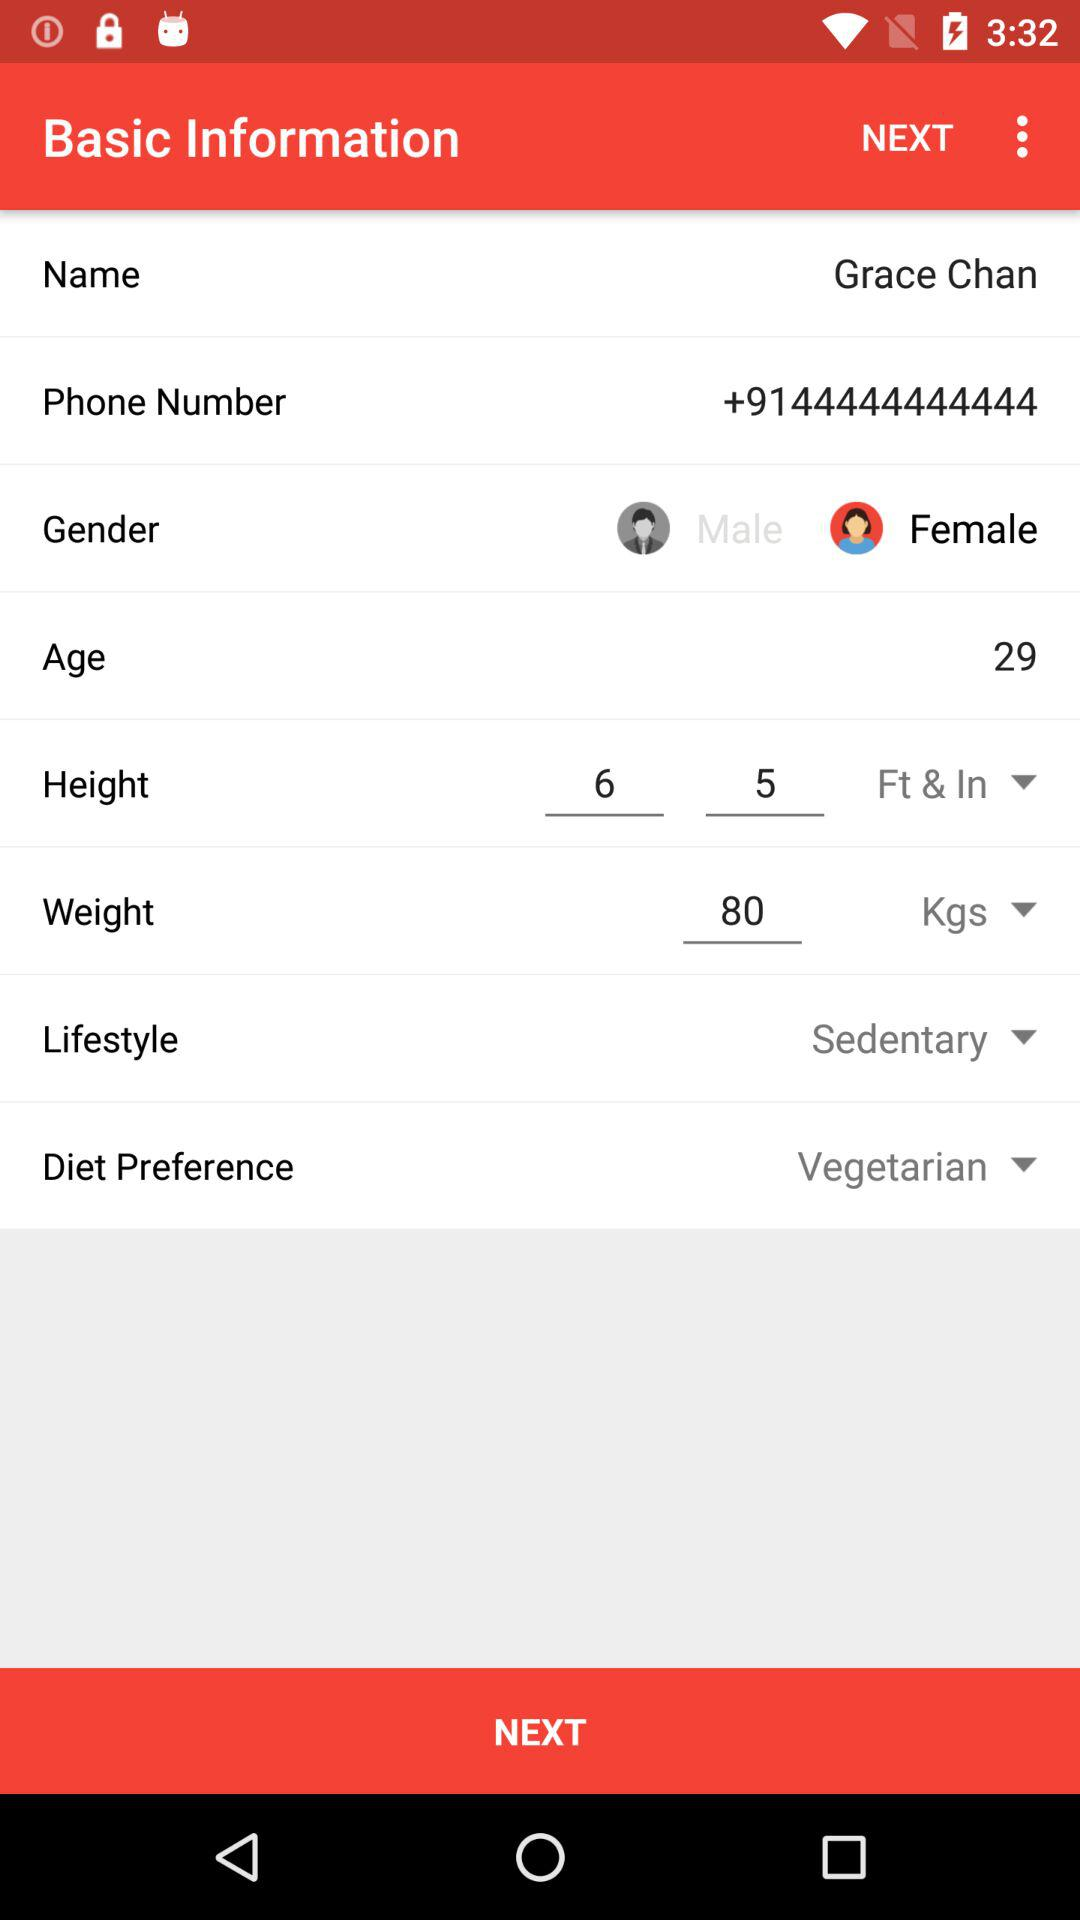What is the contact number of the user? The contact number of the user is +9144444444444. 